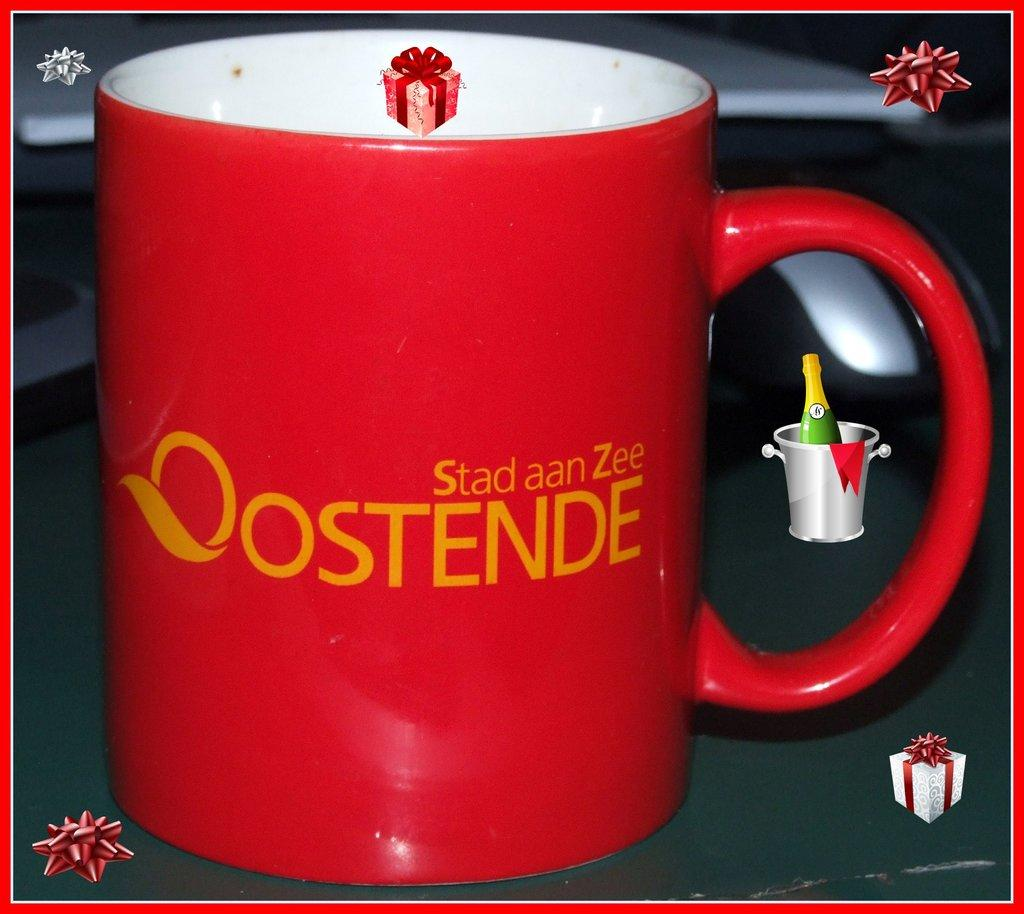<image>
Share a concise interpretation of the image provided. A red mug with orange letters says Stad aan Zee. 